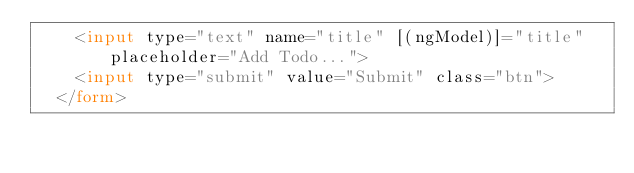Convert code to text. <code><loc_0><loc_0><loc_500><loc_500><_HTML_>    <input type="text" name="title" [(ngModel)]="title" placeholder="Add Todo...">
    <input type="submit" value="Submit" class="btn">
  </form>
</code> 